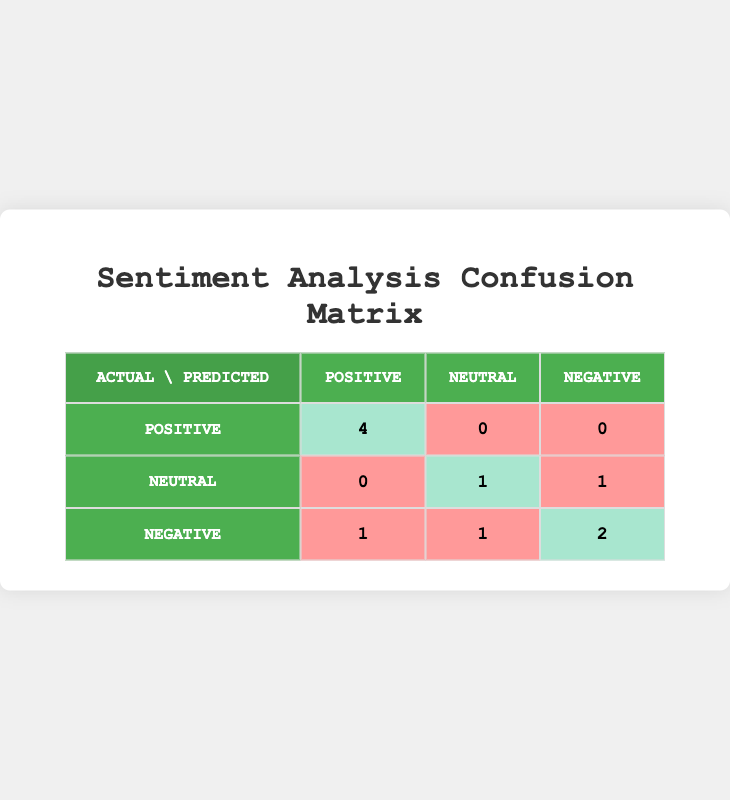What is the number of true positives in the confusion matrix? True positives are the instances where the actual sentiment was positive and the model also predicted it as positive. In the table, there are 4 true positives for actual positive sentiment.
Answer: 4 How many total predictions were classified as negative? To find the total predictions classified as negative, we sum the values in the "Negative" column of the table: 0 (from positive) + 1 (from neutral) + 2 (from negative) = 3.
Answer: 3 What percentage of the total positive reviews were correctly identified? There are 4 true positives and 1 incorrect (false negative) that was predicted as neutral or negative. So the total actual positive reviews are 4+1 = 5. Therefore, the percentage is (4/5) * 100 = 80%.
Answer: 80% Is it true that there were no false positives in the predictions? False positives occur when actual negative or neutral sentiments are incorrectly predicted as positive. Looking at the table, there are 0 predictions of actual negative or neutral sentiments classified as positive, confirming that there were no false positives.
Answer: Yes What is the total number of true negatives in the confusion matrix? True negatives are the instances where the model correctly predicted negative sentiment. In this case, that is represented by 2 (from actual negative) with no predictions erroneously labeled as negative from positives or neutrals. So the total true negatives are 2.
Answer: 2 What is the combined total for false negatives and false positives in the confusion matrix? False negatives are identified as predictions where positive sentiments are incorrectly predicted as neutral or negative (0 in this case). False positives are also 0, as stated above. Therefore, the total for false negatives and false positives is 0 + 0 = 0.
Answer: 0 How many predictions were classified as neutral? The neutral predictions can be summed up from the table: 0 (from positive) + 1 (from neutral) + 1 (from negative) = 2. Thus, there are 2 predictions classified as neutral.
Answer: 2 If the model had to predict a new review, what is the likelihood it could be correct based on the true positive rate? The true positive rate (sensitivity) is calculated as the true positives divided by the total actual positives. Using the previous calculations, this is 4 true positives over 5 total positives. Therefore, the correct likelihood rate is (4/5) = 80%.
Answer: 80% 